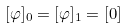<formula> <loc_0><loc_0><loc_500><loc_500>[ \varphi ] _ { 0 } = [ \varphi ] _ { 1 } = [ 0 ]</formula> 